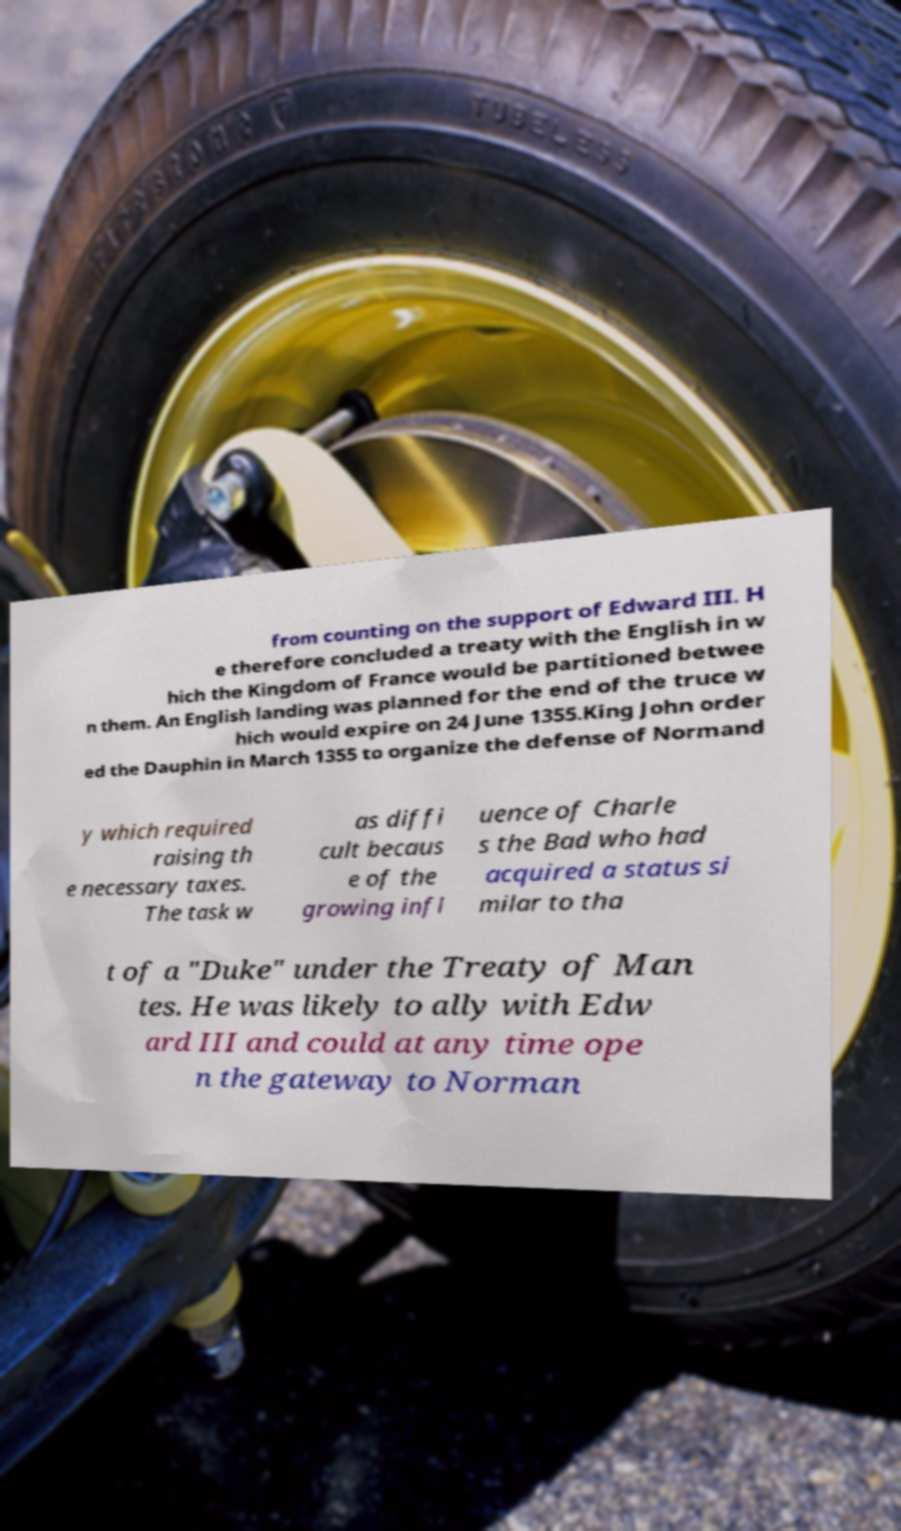I need the written content from this picture converted into text. Can you do that? from counting on the support of Edward III. H e therefore concluded a treaty with the English in w hich the Kingdom of France would be partitioned betwee n them. An English landing was planned for the end of the truce w hich would expire on 24 June 1355.King John order ed the Dauphin in March 1355 to organize the defense of Normand y which required raising th e necessary taxes. The task w as diffi cult becaus e of the growing infl uence of Charle s the Bad who had acquired a status si milar to tha t of a "Duke" under the Treaty of Man tes. He was likely to ally with Edw ard III and could at any time ope n the gateway to Norman 